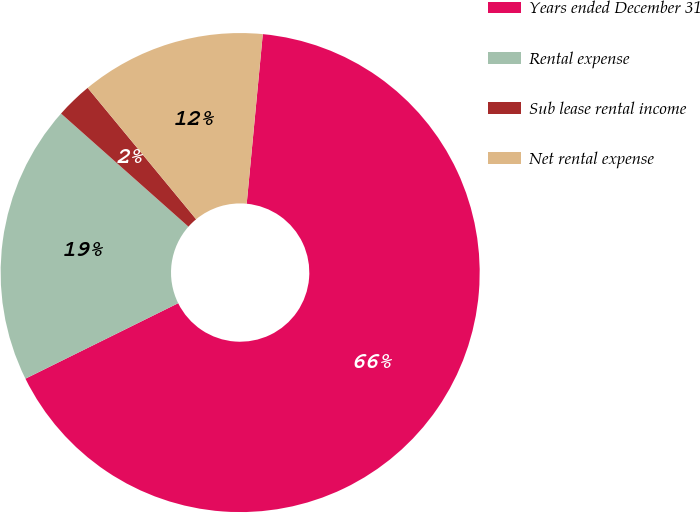Convert chart to OTSL. <chart><loc_0><loc_0><loc_500><loc_500><pie_chart><fcel>Years ended December 31<fcel>Rental expense<fcel>Sub lease rental income<fcel>Net rental expense<nl><fcel>66.19%<fcel>18.86%<fcel>2.46%<fcel>12.49%<nl></chart> 